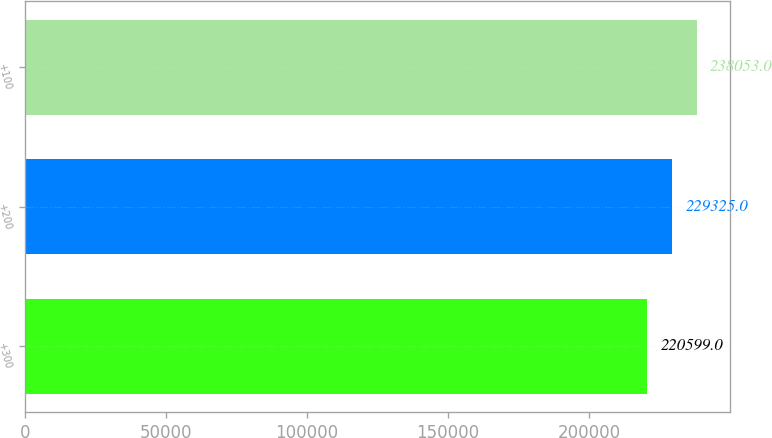Convert chart. <chart><loc_0><loc_0><loc_500><loc_500><bar_chart><fcel>+300<fcel>+200<fcel>+100<nl><fcel>220599<fcel>229325<fcel>238053<nl></chart> 